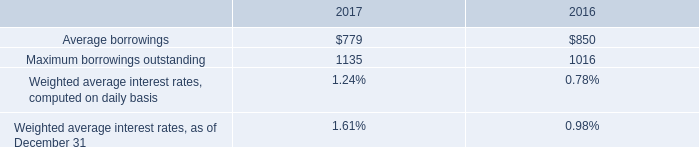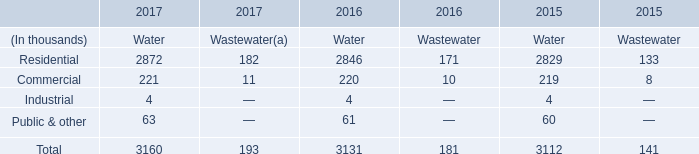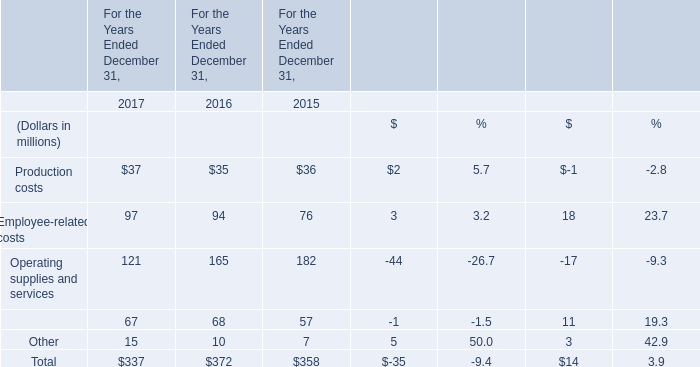by what percentage did maximum borrowings outstanding increase from 2016 to 2017? 
Computations: ((1135 - 1016) / 1016)
Answer: 0.11713. what was the percent growth of borrowings outstanding from 2016 to 2017 
Computations: ((1135 - 1016) / 1016)
Answer: 0.11713. What will Total be like in 2018 if it continues to grow at the same rate as it did in 2017? (in million) 
Computations: (exp((1 + ((337 - 372) / 372)) * 2))
Answer: 276.56921. 